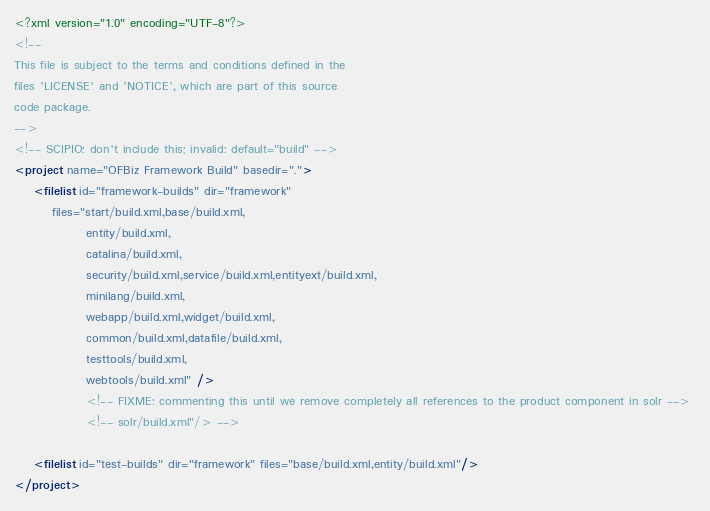Convert code to text. <code><loc_0><loc_0><loc_500><loc_500><_XML_><?xml version="1.0" encoding="UTF-8"?>
<!--
This file is subject to the terms and conditions defined in the
files 'LICENSE' and 'NOTICE', which are part of this source
code package.
-->
<!-- SCIPIO: don't include this; invalid: default="build" -->
<project name="OFBiz Framework Build" basedir=".">
    <filelist id="framework-builds" dir="framework"
        files="start/build.xml,base/build.xml,
               entity/build.xml,
               catalina/build.xml,
               security/build.xml,service/build.xml,entityext/build.xml,
               minilang/build.xml,
               webapp/build.xml,widget/build.xml,
               common/build.xml,datafile/build.xml,
               testtools/build.xml,
               webtools/build.xml" />
               <!-- FIXME: commenting this until we remove completely all references to the product component in solr --> 
               <!-- solr/build.xml"/> -->

    <filelist id="test-builds" dir="framework" files="base/build.xml,entity/build.xml"/>
</project>
</code> 